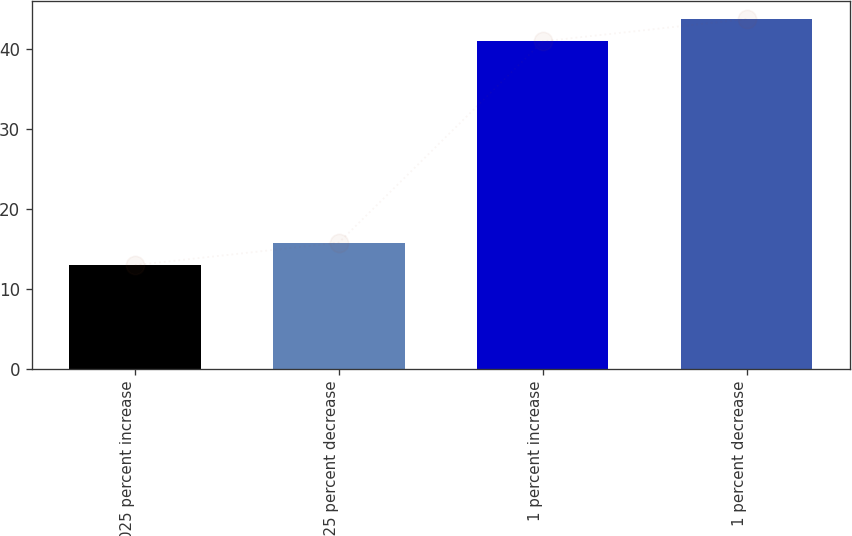Convert chart. <chart><loc_0><loc_0><loc_500><loc_500><bar_chart><fcel>025 percent increase<fcel>025 percent decrease<fcel>1 percent increase<fcel>1 percent decrease<nl><fcel>13<fcel>15.8<fcel>41<fcel>43.8<nl></chart> 